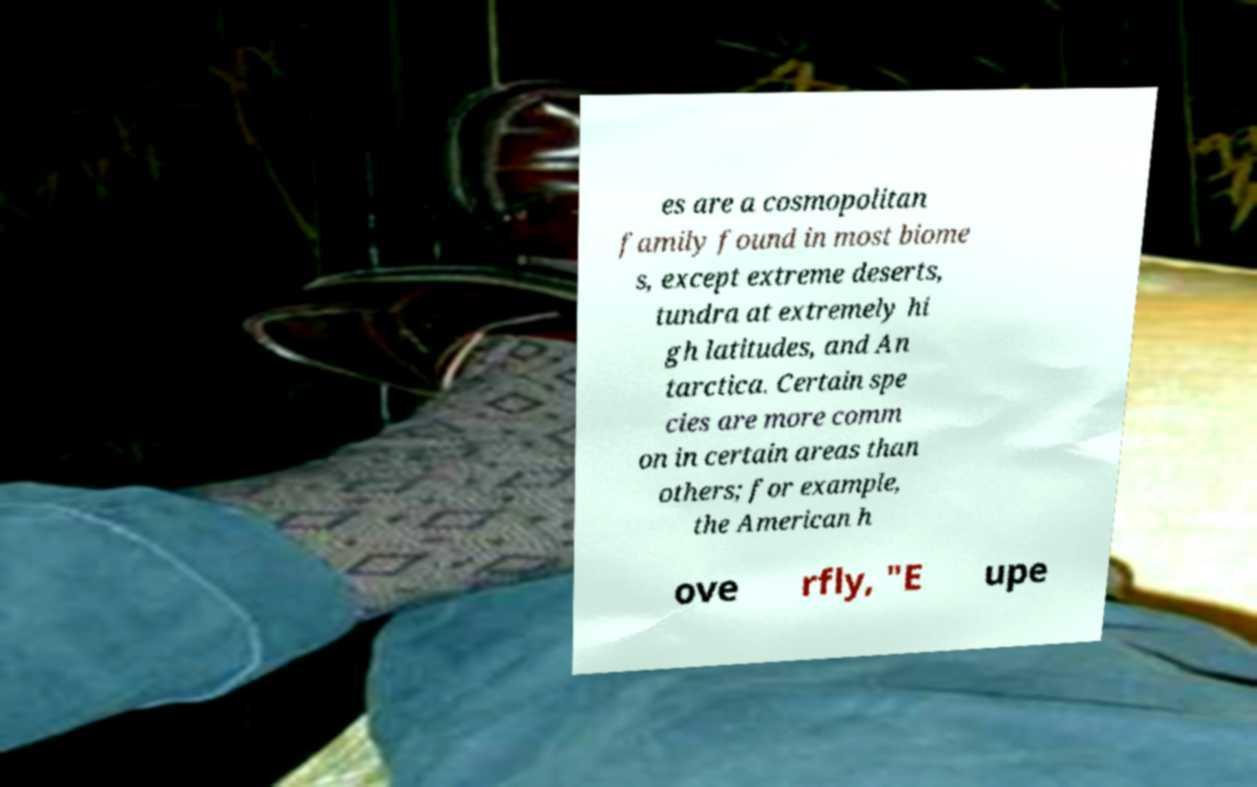Can you accurately transcribe the text from the provided image for me? es are a cosmopolitan family found in most biome s, except extreme deserts, tundra at extremely hi gh latitudes, and An tarctica. Certain spe cies are more comm on in certain areas than others; for example, the American h ove rfly, "E upe 